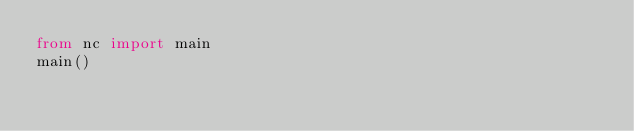<code> <loc_0><loc_0><loc_500><loc_500><_Python_>from nc import main
main()
</code> 